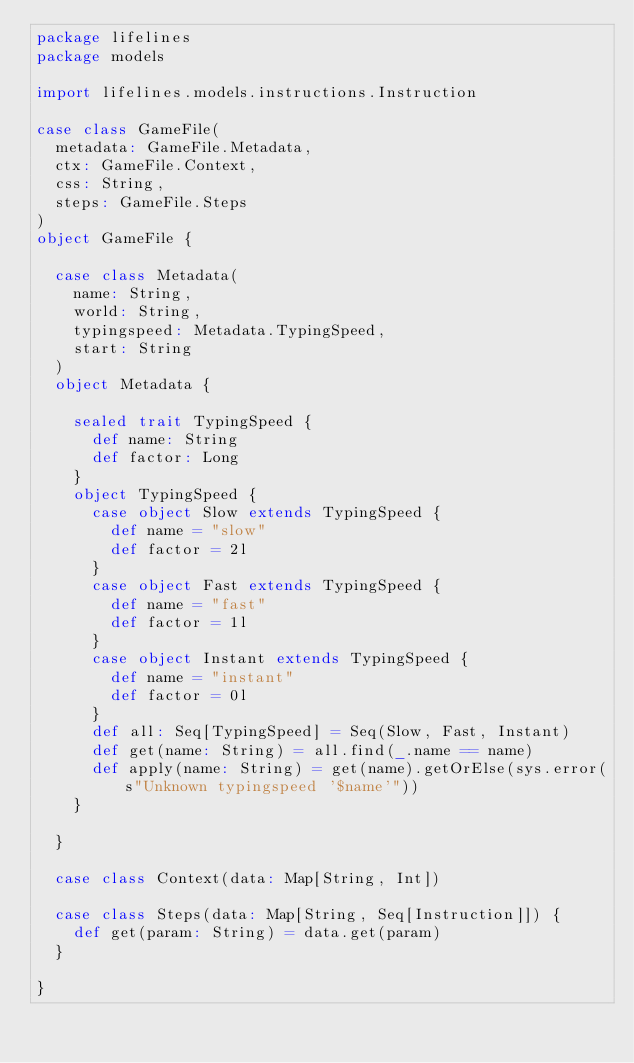<code> <loc_0><loc_0><loc_500><loc_500><_Scala_>package lifelines
package models

import lifelines.models.instructions.Instruction

case class GameFile(
  metadata: GameFile.Metadata,
  ctx: GameFile.Context,
  css: String,
  steps: GameFile.Steps
)
object GameFile {

  case class Metadata(
    name: String,
    world: String,
    typingspeed: Metadata.TypingSpeed,
    start: String
  )
  object Metadata {

    sealed trait TypingSpeed {
      def name: String
      def factor: Long
    }
    object TypingSpeed {
      case object Slow extends TypingSpeed {
        def name = "slow"
        def factor = 2l
      }
      case object Fast extends TypingSpeed {
        def name = "fast"
        def factor = 1l
      }
      case object Instant extends TypingSpeed {
        def name = "instant"
        def factor = 0l
      }
      def all: Seq[TypingSpeed] = Seq(Slow, Fast, Instant)
      def get(name: String) = all.find(_.name == name)
      def apply(name: String) = get(name).getOrElse(sys.error(s"Unknown typingspeed '$name'"))
    }

  }

  case class Context(data: Map[String, Int])

  case class Steps(data: Map[String, Seq[Instruction]]) {
    def get(param: String) = data.get(param)
  }

}
</code> 